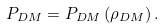<formula> <loc_0><loc_0><loc_500><loc_500>P _ { D M } = P _ { D M } \left ( \rho _ { D M } \right ) .</formula> 